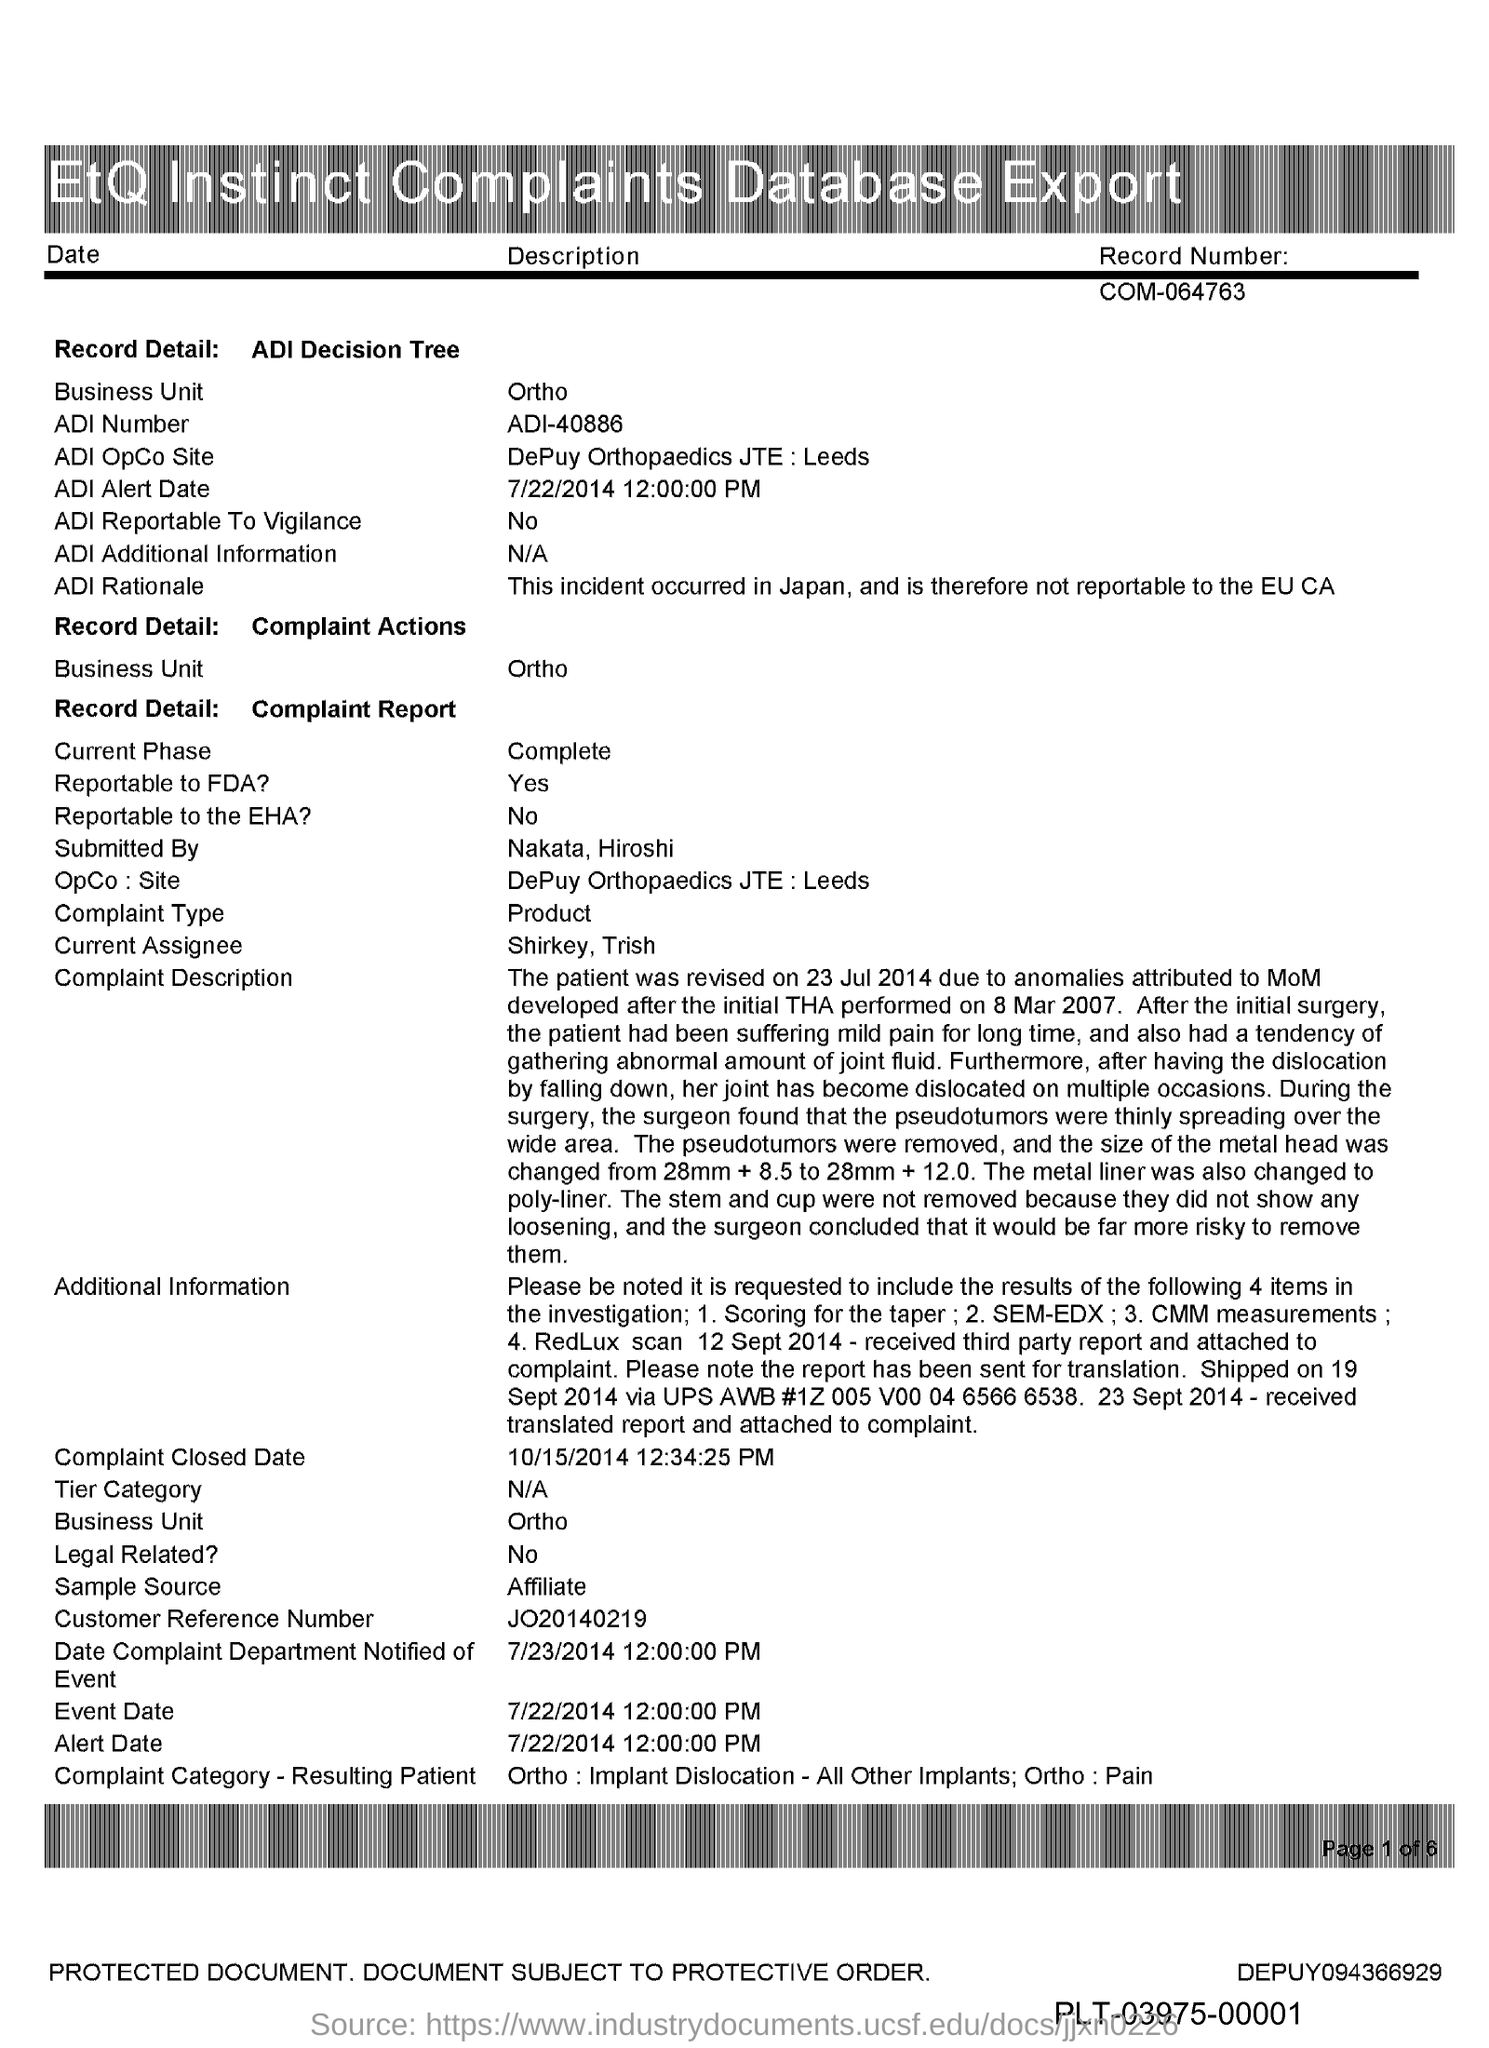What is the title of the document?
Provide a succinct answer. Etq Instinct Complaints Database Export. What is the ADI Number?
Make the answer very short. ADI-40886. What is the Record Number?
Offer a very short reply. COM-064763. 